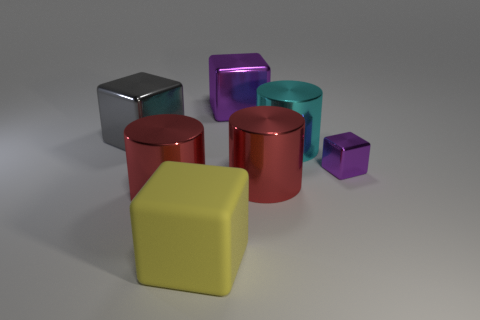What number of small things are either matte cubes or brown metallic objects?
Offer a terse response. 0. What is the size of the red cylinder that is on the left side of the cube in front of the purple thing in front of the cyan shiny cylinder?
Keep it short and to the point. Large. Is there anything else that has the same color as the small metal object?
Provide a short and direct response. Yes. There is a purple cube that is behind the gray cube that is in front of the purple metallic object that is behind the large cyan shiny thing; what is it made of?
Ensure brevity in your answer.  Metal. Is the small thing the same shape as the big purple thing?
Ensure brevity in your answer.  Yes. Is there any other thing that is made of the same material as the small object?
Your answer should be very brief. Yes. How many purple blocks are both on the right side of the cyan metal cylinder and behind the large gray object?
Provide a short and direct response. 0. What color is the small thing behind the large matte cube in front of the small object?
Your answer should be very brief. Purple. Is the number of red shiny objects behind the gray object the same as the number of red metallic cylinders?
Your answer should be very brief. No. What number of large metallic cylinders are in front of the purple metallic object that is in front of the purple shiny cube behind the tiny purple metallic thing?
Your answer should be compact. 2. 